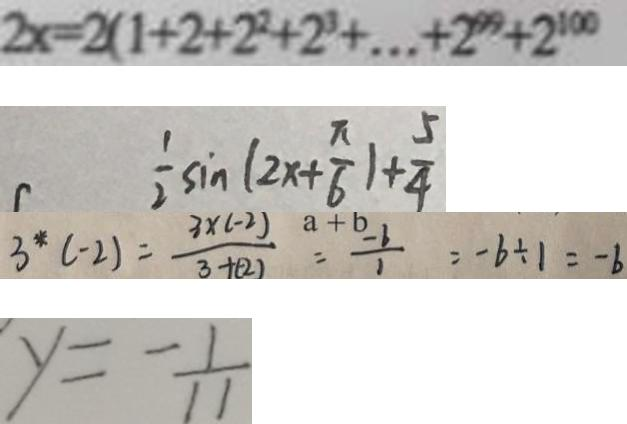<formula> <loc_0><loc_0><loc_500><loc_500>2 x = 2 ( 1 + 2 + 2 ^ { 2 } + 2 ^ { 3 } + \cdots + 2 ^ { 9 9 } + 2 ^ { 1 0 0 } 
 \frac { 1 } { 2 } \sin ( 2 x + \frac { \pi } { 6 } ) + \frac { 5 } { 4 } 
 3 ^ { \ast } ( - 2 ) = \frac { 3 \times ( - 2 ) } { 3 + ( - 2 ) } = - \frac { - b } { 1 } = - b \div 1 = - b 
 y = - \frac { 1 } { 1 1 }</formula> 